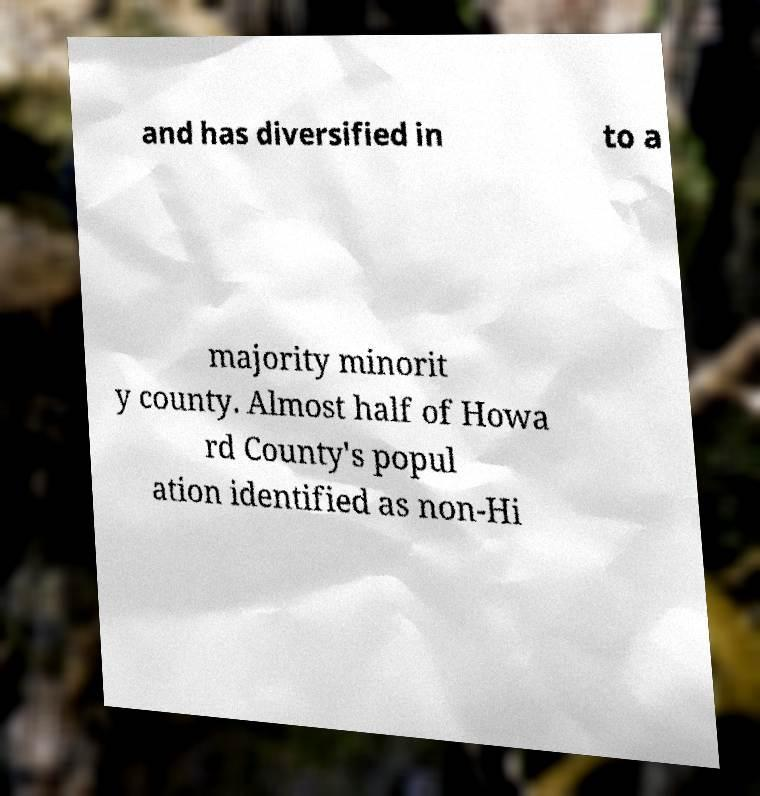Can you accurately transcribe the text from the provided image for me? The text from the image reads: 'and has diversified into a majority minority county. Almost half of Howard County's population identified as non-Hispanic.' 